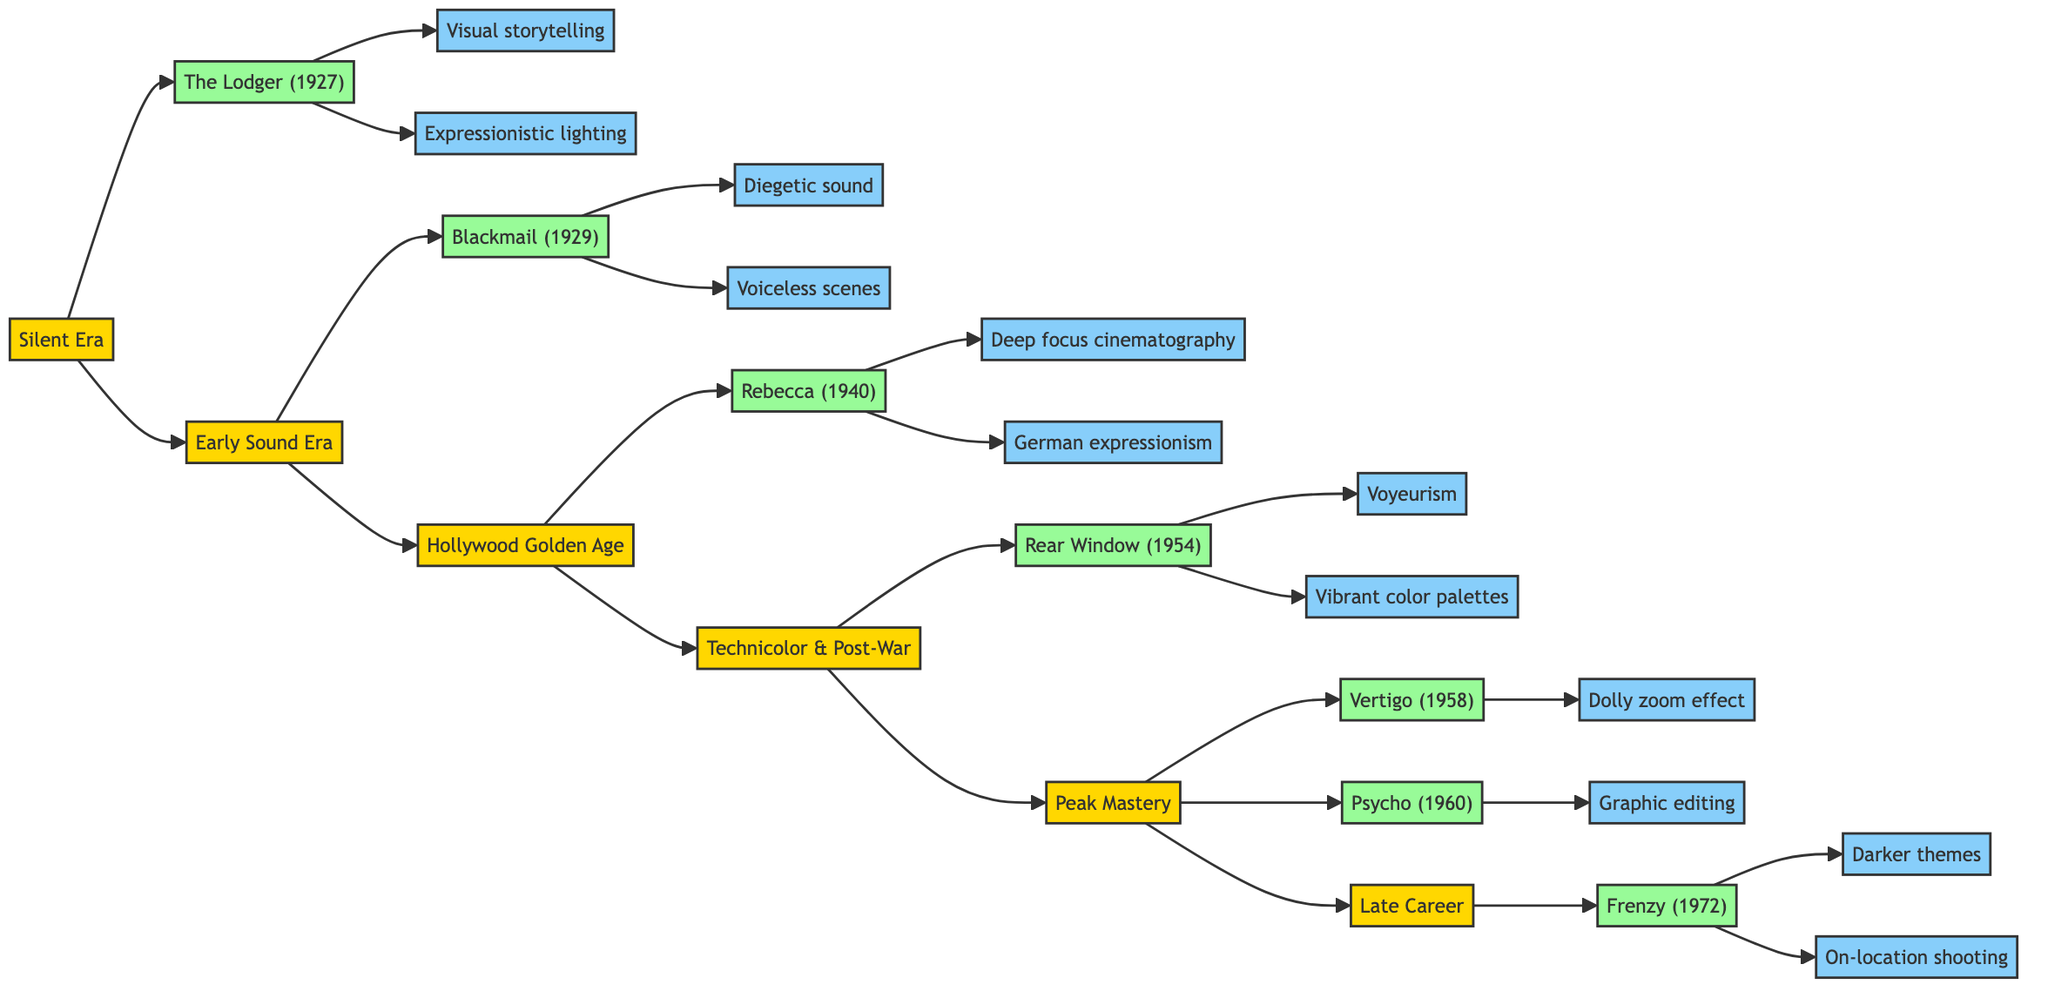What film is associated with the Silent Era? The diagram indicates that "The Lodger: A Story of the London Fog" is the film example linked to the Silent Era stage.
Answer: The Lodger: A Story of the London Fog (1927) How many film examples are listed under the Peak Mastery stage? According to the diagram, there are three film examples listed under the Peak Mastery stage: "Vertigo," "Psycho," and "The Birds."
Answer: 3 What technique is associated with Blackmail (1929)? The flowchart connects "Blackmail" (1929) with the technique of "Diegetic sound." Therefore, this is the associated technique.
Answer: Diegetic sound Which stage follows the Hollywood Golden Age? The organization of the diagram shows a progression from "Hollywood Golden Age" to "Technicolor & Post-War." This indicates the following stage.
Answer: Technicolor & Post-War What is one of the techniques used in Rear Window (1954)? According to the diagram, "Rear Window" utilizes "Voyeurism" as one of its techniques. This response summarizes the information effectively.
Answer: Voyeurism How many techniques are listed for the Late Career stage? The flowchart presents two techniques associated with the Late Career stage: "Darker themes" and "On-location shooting." Thus, the count is derived from these two listed techniques.
Answer: 2 Which technique is associated with Vertigo (1958)? The diagram directly links the technique "Dolly zoom effect" specifically to the film "Vertigo" within the Peak Mastery stage.
Answer: Dolly zoom effect What thematic shift is noted in the Late Career stage? The flowchart explains that "Return to darker themes" is a noted thematic shift during Hitchcock's Late Career stage, indicating a significant change in his thematic focus.
Answer: Darker themes 